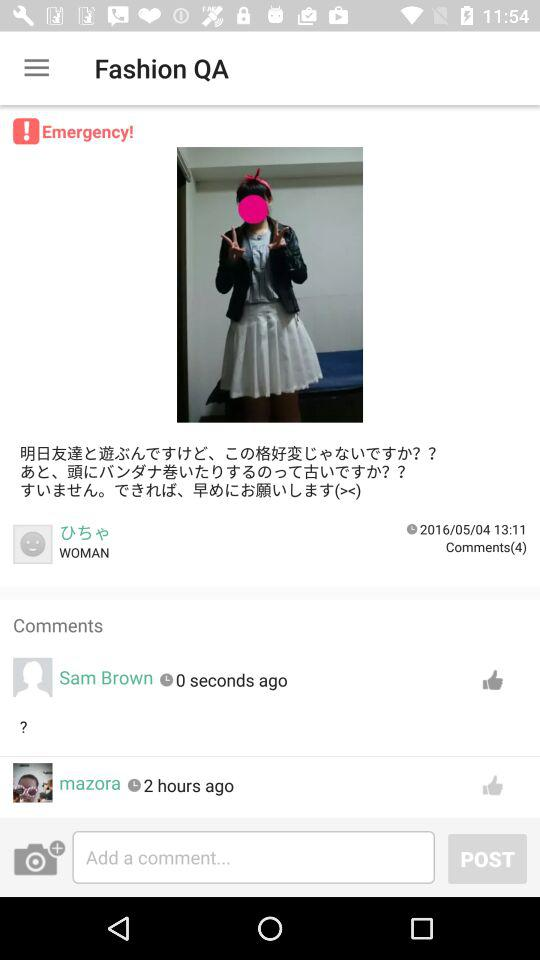How many comments are there on this post?
Answer the question using a single word or phrase. 4 